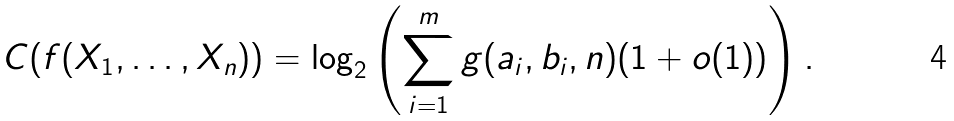<formula> <loc_0><loc_0><loc_500><loc_500>C ( f ( X _ { 1 } , \dots , X _ { n } ) ) = \log _ { 2 } \left ( \sum _ { i = 1 } ^ { m } g ( a _ { i } , b _ { i } , n ) ( 1 + o ( 1 ) ) \right ) .</formula> 